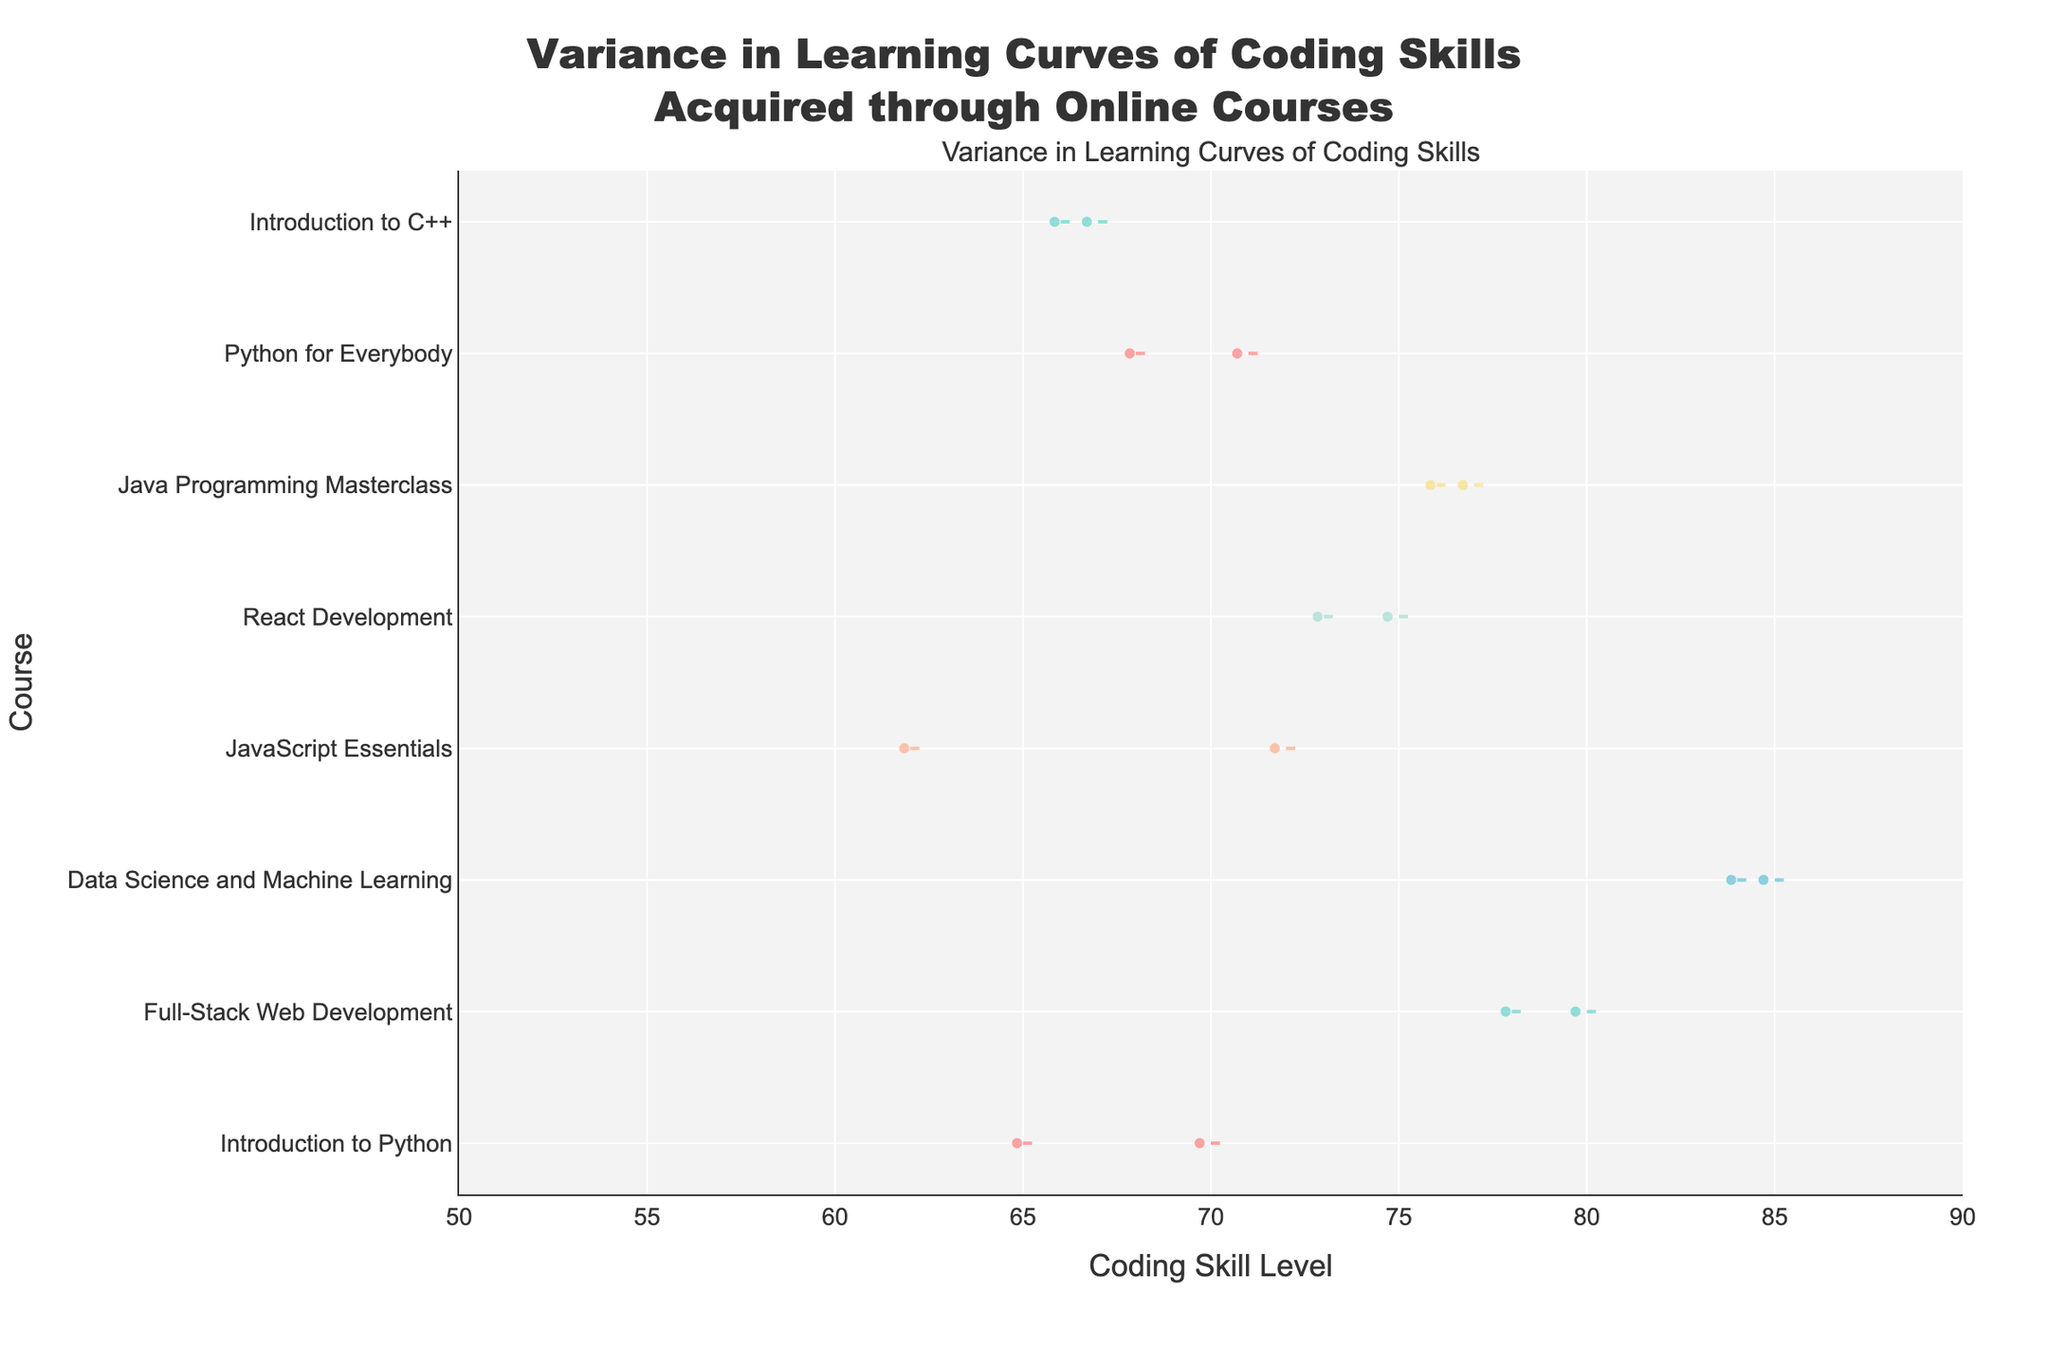What is the title of the chart? The title of the chart is usually located at the top. In this case, it states, "Variance in Learning Curves of Coding Skills Acquired through Online Courses."
Answer: Variance in Learning Curves of Coding Skills Acquired through Online Courses How many courses are analyzed in the chart? By counting the unique courses listed on the y-axis, we can determine the number of courses. These courses would be represented by the violins.
Answer: 8 Which course has the highest coding skill level on average? By observing the central tendency indicators (such as the mean line) in each violin plot, the course with the highest mean coding skill level can be identified.
Answer: Data Science and Machine Learning What is the range of coding skill levels for the "Full-Stack Web Development" course? For the "Full-Stack Web Development" course, look at the horizontal spread of the violin plot. The range is determined by the lowest and highest points visible within the violin.
Answer: 78-80 Which platform offers the "React Development" course? The platform offering a course can sometimes be indicated within the data, often requiring noting the course name and mentally mapping it back to earlier shared data if needed. For "React Development," it should be in the dataset provided.
Answer: Pluralsight Between "Introduction to Python" and "Python for Everybody," which course shows a wider variance in coding skill levels? Variance in the skill levels for courses can be observed by the width and spread of the violin plots. The course with a wider or more spread out violin indicates greater variance.
Answer: Introduction to Python How many data points are there in the "Introduction to C++" course? The data points within a violin are indicated by the jittered positions or boxes. Each dot represents one student, so counting the dots will give the number of data points.
Answer: 2 Which course has the lowest minimum coding skill level? Observing the bottom-most position of each violin plot can help identify which course has the lowest minimum coding skill level.
Answer: Introduction to C++ What is the coding skill level range for "React Development"? The spread of the violin from left to right will show the range of coding skill levels for "React Development." Observing these extremities gives the range.
Answer: 73-75 